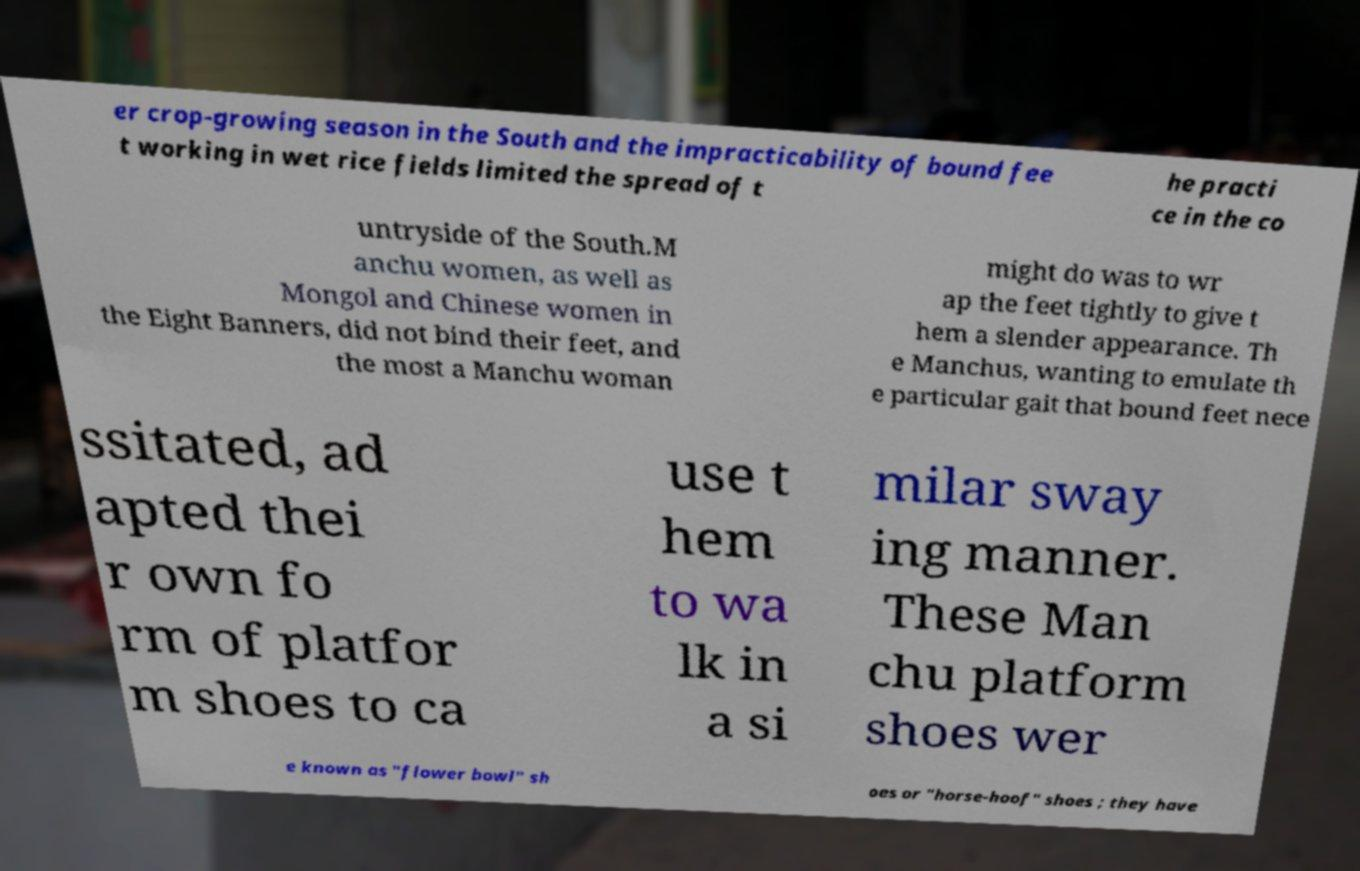What messages or text are displayed in this image? I need them in a readable, typed format. er crop-growing season in the South and the impracticability of bound fee t working in wet rice fields limited the spread of t he practi ce in the co untryside of the South.M anchu women, as well as Mongol and Chinese women in the Eight Banners, did not bind their feet, and the most a Manchu woman might do was to wr ap the feet tightly to give t hem a slender appearance. Th e Manchus, wanting to emulate th e particular gait that bound feet nece ssitated, ad apted thei r own fo rm of platfor m shoes to ca use t hem to wa lk in a si milar sway ing manner. These Man chu platform shoes wer e known as "flower bowl" sh oes or "horse-hoof" shoes ; they have 